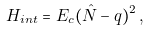<formula> <loc_0><loc_0><loc_500><loc_500>H _ { i n t } = E _ { c } ( \hat { N } - q ) ^ { 2 } \, ,</formula> 